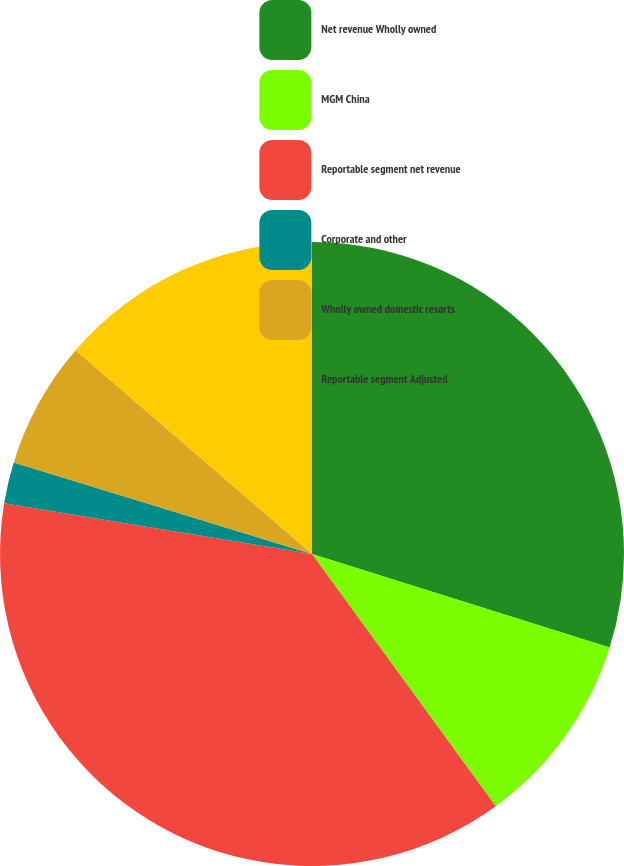Convert chart to OTSL. <chart><loc_0><loc_0><loc_500><loc_500><pie_chart><fcel>Net revenue Wholly owned<fcel>MGM China<fcel>Reportable segment net revenue<fcel>Corporate and other<fcel>Wholly owned domestic resorts<fcel>Reportable segment Adjusted<nl><fcel>29.85%<fcel>10.13%<fcel>37.63%<fcel>2.14%<fcel>6.58%<fcel>13.68%<nl></chart> 